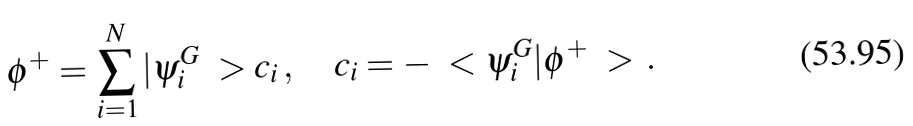Convert formula to latex. <formula><loc_0><loc_0><loc_500><loc_500>\phi ^ { + } = \sum _ { i = 1 } ^ { N } | \psi _ { i } ^ { G } \ > c _ { i } \, , \quad c _ { i } = - \ < \psi _ { i } ^ { G } | \phi ^ { + } \ > \, .</formula> 